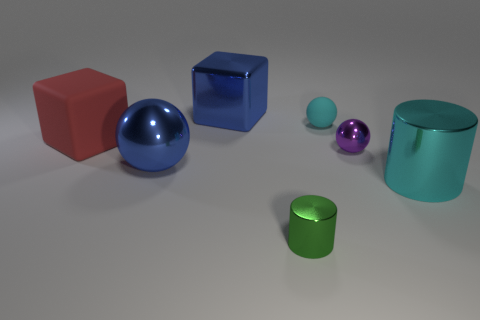Are there any metal balls that have the same color as the large metallic block?
Offer a terse response. Yes. The tiny shiny object that is behind the large cyan cylinder has what shape?
Ensure brevity in your answer.  Sphere. The big rubber cube has what color?
Your answer should be very brief. Red. What is the color of the block that is the same material as the purple sphere?
Provide a succinct answer. Blue. How many other small green objects have the same material as the small green object?
Your response must be concise. 0. What number of blue metal balls are behind the large red thing?
Your answer should be compact. 0. Do the big object behind the large red cube and the cyan object behind the big blue metal sphere have the same material?
Your answer should be very brief. No. Are there more big cyan objects behind the small purple metallic thing than cubes left of the tiny cyan rubber sphere?
Offer a very short reply. No. There is a big cylinder that is the same color as the rubber sphere; what is its material?
Make the answer very short. Metal. There is a tiny thing that is both in front of the large red thing and behind the tiny green metallic object; what material is it?
Provide a succinct answer. Metal. 